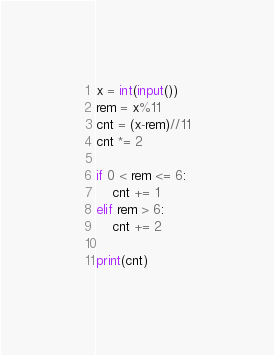<code> <loc_0><loc_0><loc_500><loc_500><_Python_>x = int(input())
rem = x%11
cnt = (x-rem)//11
cnt *= 2

if 0 < rem <= 6:
    cnt += 1
elif rem > 6:
    cnt += 2

print(cnt)</code> 